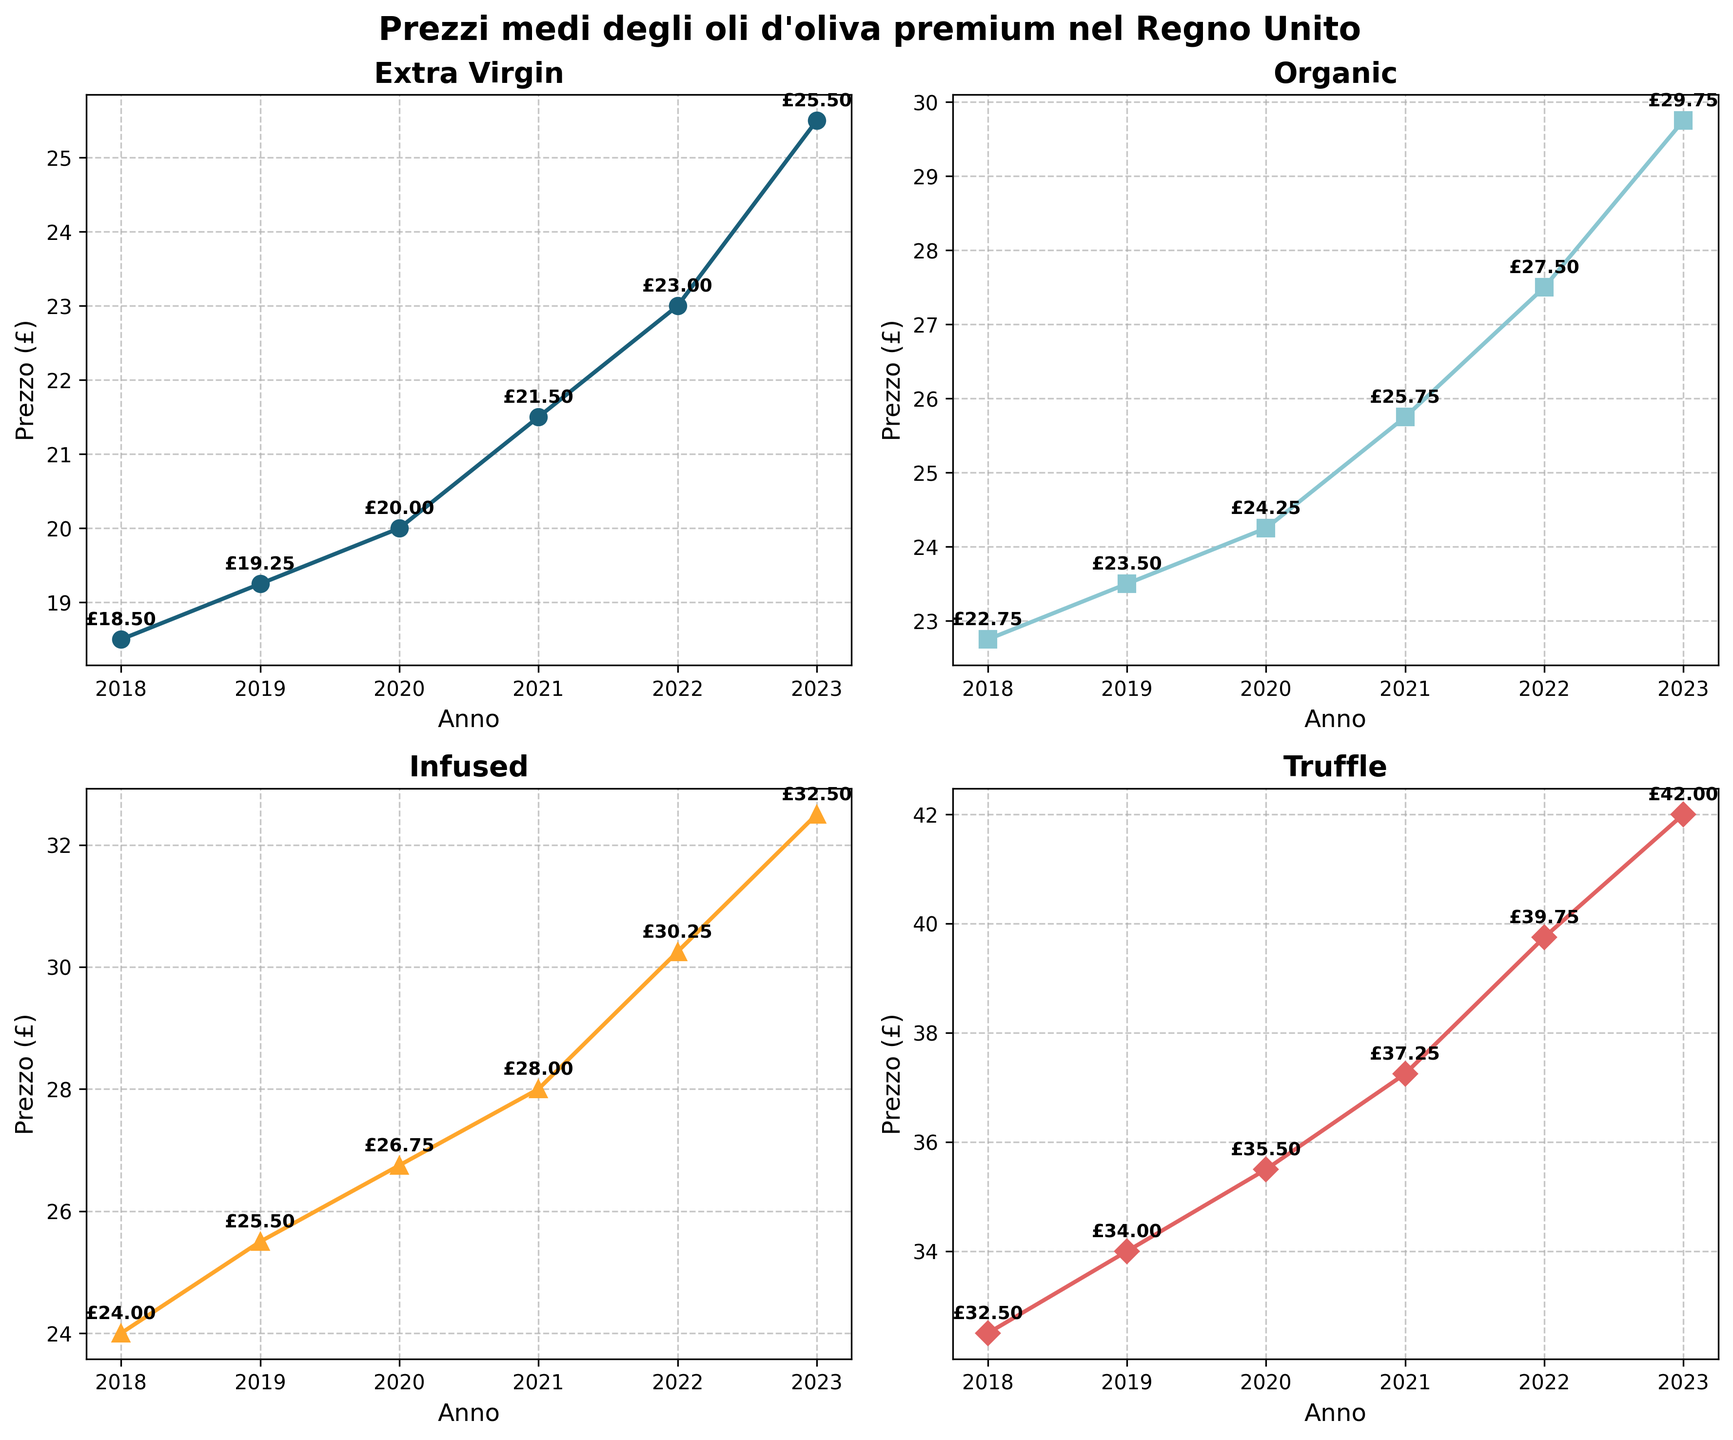what is the title of the figure? The title of the figure is stated at the top. The exact wording is visible on the figure.
Answer: Prezzi medi degli oli d'oliva premium nel Regno Unito Which type of olive oil had the highest price in 2018? Look at the data point for 2018 on all four line charts. The highest price among them is the one for Truffle.
Answer: Truffle How has the price of Extra Virgin olive oil changed from 2018 to 2023? From 2018 to 2023, check the data points on the line chart for Extra Virgin olive oil. The price increased from £18.50 in 2018 to £25.50 in 2023.
Answer: Increased What is the average price of Organic olive oil over the years shown? Add the prices of Organic olive oil from 2018 to 2023 and divide by the number of years: (22.75 + 23.50 + 24.25 + 25.75 + 27.50 + 29.75) / 6 = 25.58
Answer: £25.58 Between Organic and Infused olive oils, which one had more consistent pricing over the years? Examine the price changes for both Organic and Infused olive oils and see which has the more stable (smaller) year-to-year changes. Infused olive oil has smaller changes compared to Organic, indicating more consistency.
Answer: Infused What price did Truffle olive oil reach in 2022? Look at the data point for Truffle olive oil in 2022 on its line chart. The price is indicated there.
Answer: £39.75 Are there any years where the price of Extra Virgin olive oil decreased compared to the previous year? Check the year-to-year comparison of Extra Virgin olive oil prices. Each year from 2018 to 2023 shows an increase.
Answer: No 